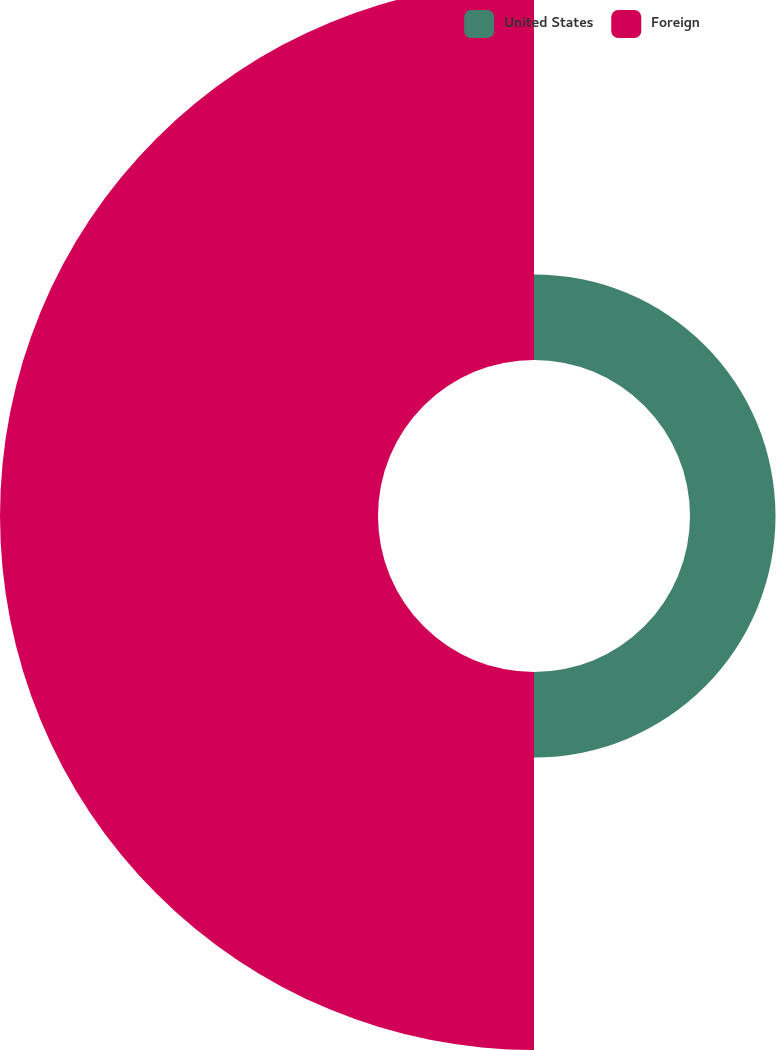Convert chart to OTSL. <chart><loc_0><loc_0><loc_500><loc_500><pie_chart><fcel>United States<fcel>Foreign<nl><fcel>18.45%<fcel>81.55%<nl></chart> 